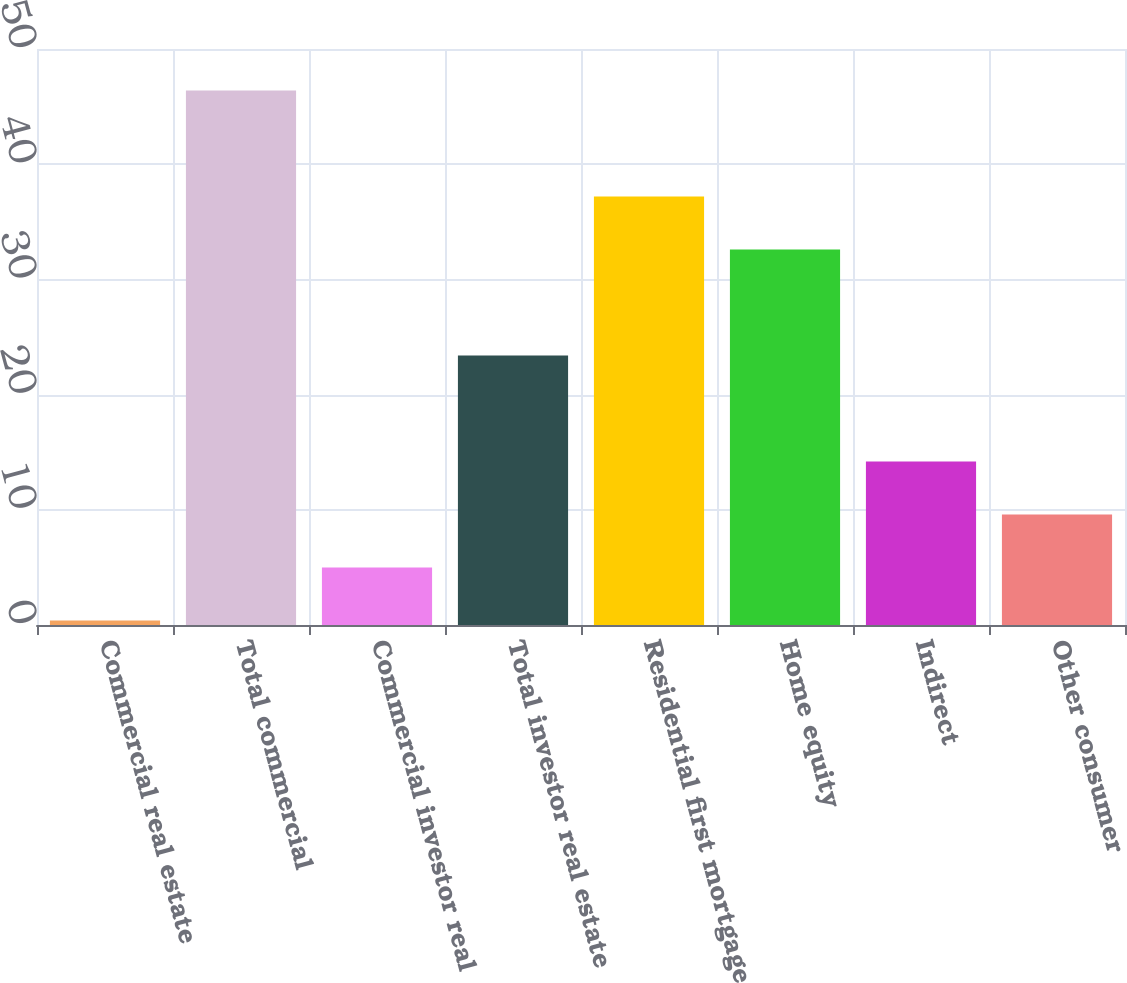Convert chart to OTSL. <chart><loc_0><loc_0><loc_500><loc_500><bar_chart><fcel>Commercial real estate<fcel>Total commercial<fcel>Commercial investor real<fcel>Total investor real estate<fcel>Residential first mortgage<fcel>Home equity<fcel>Indirect<fcel>Other consumer<nl><fcel>0.4<fcel>46.4<fcel>5<fcel>23.4<fcel>37.2<fcel>32.6<fcel>14.2<fcel>9.6<nl></chart> 